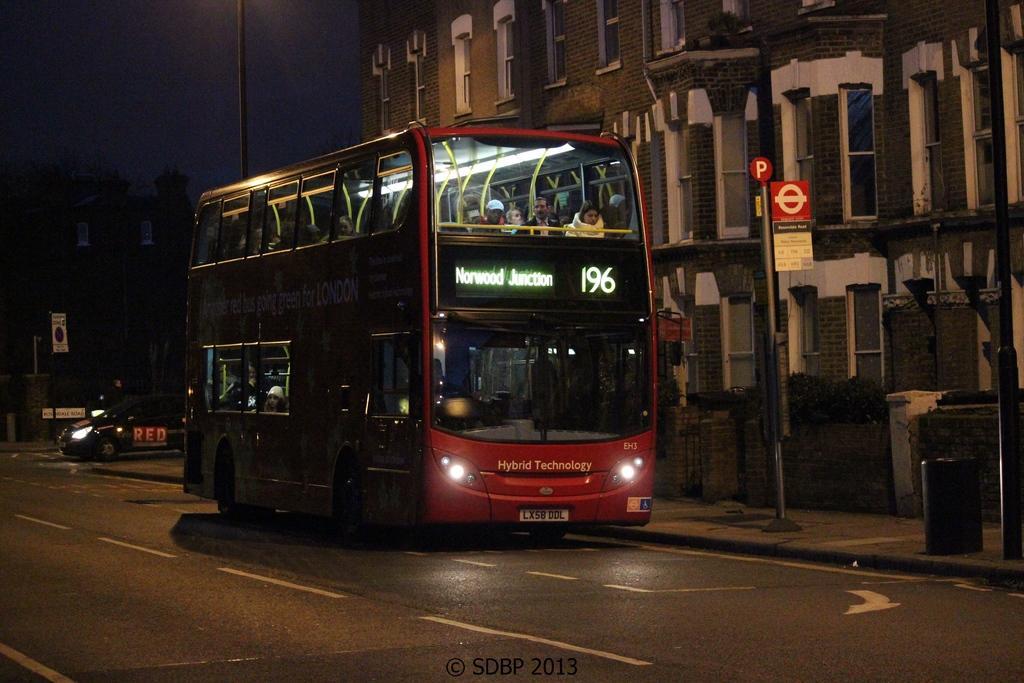In one or two sentences, can you explain what this image depicts? In this image on a road a double decker bus is moving. Inside it there are many people. Hire a car is moving on the road. There are sign boards beside the road. In the background there are buildings. In the foreground there is a road. 